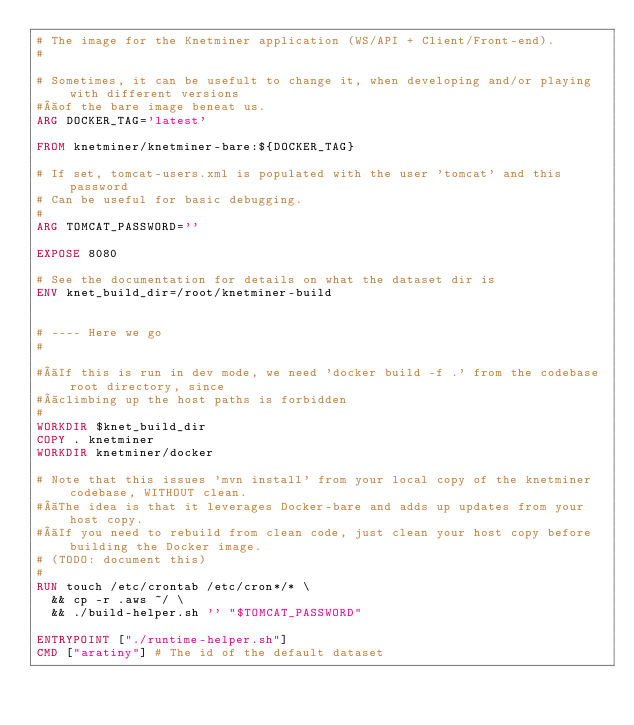Convert code to text. <code><loc_0><loc_0><loc_500><loc_500><_Dockerfile_># The image for the Knetminer application (WS/API + Client/Front-end).
#

# Sometimes, it can be usefult to change it, when developing and/or playing with different versions
# of the bare image beneat us.
ARG DOCKER_TAG='latest' 

FROM knetminer/knetminer-bare:${DOCKER_TAG}

# If set, tomcat-users.xml is populated with the user 'tomcat' and this password
# Can be useful for basic debugging.
#
ARG TOMCAT_PASSWORD=''

EXPOSE 8080

# See the documentation for details on what the dataset dir is
ENV knet_build_dir=/root/knetminer-build


# ---- Here we go
# 

# If this is run in dev mode, we need 'docker build -f .' from the codebase root directory, since
# climbing up the host paths is forbidden
#
WORKDIR $knet_build_dir
COPY . knetminer
WORKDIR knetminer/docker

# Note that this issues 'mvn install' from your local copy of the knetminer codebase, WITHOUT clean.
# The idea is that it leverages Docker-bare and adds up updates from your host copy. 
# If you need to rebuild from clean code, just clean your host copy before building the Docker image.
# (TODO: document this)
# 
RUN touch /etc/crontab /etc/cron*/* \
  && cp -r .aws ~/ \
  && ./build-helper.sh '' "$TOMCAT_PASSWORD"

ENTRYPOINT ["./runtime-helper.sh"] 
CMD ["aratiny"] # The id of the default dataset
</code> 